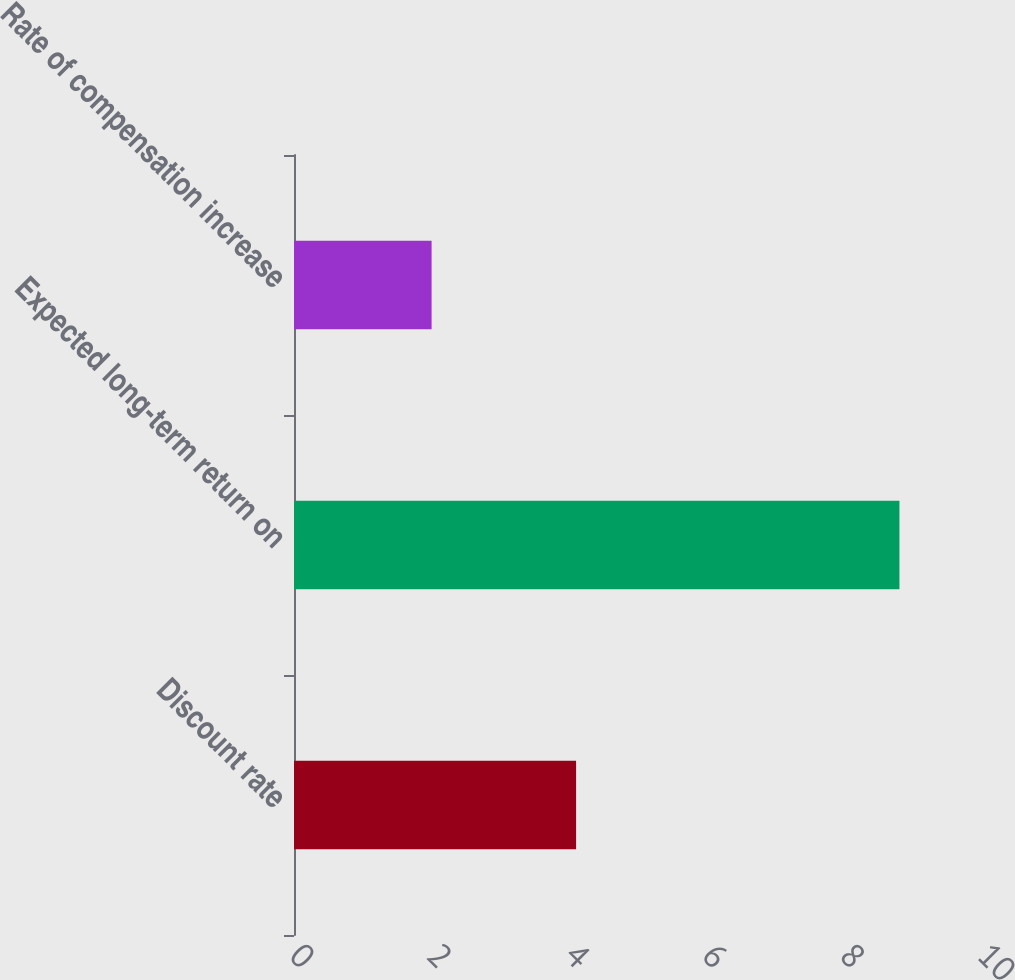Convert chart to OTSL. <chart><loc_0><loc_0><loc_500><loc_500><bar_chart><fcel>Discount rate<fcel>Expected long-term return on<fcel>Rate of compensation increase<nl><fcel>4.1<fcel>8.8<fcel>2<nl></chart> 